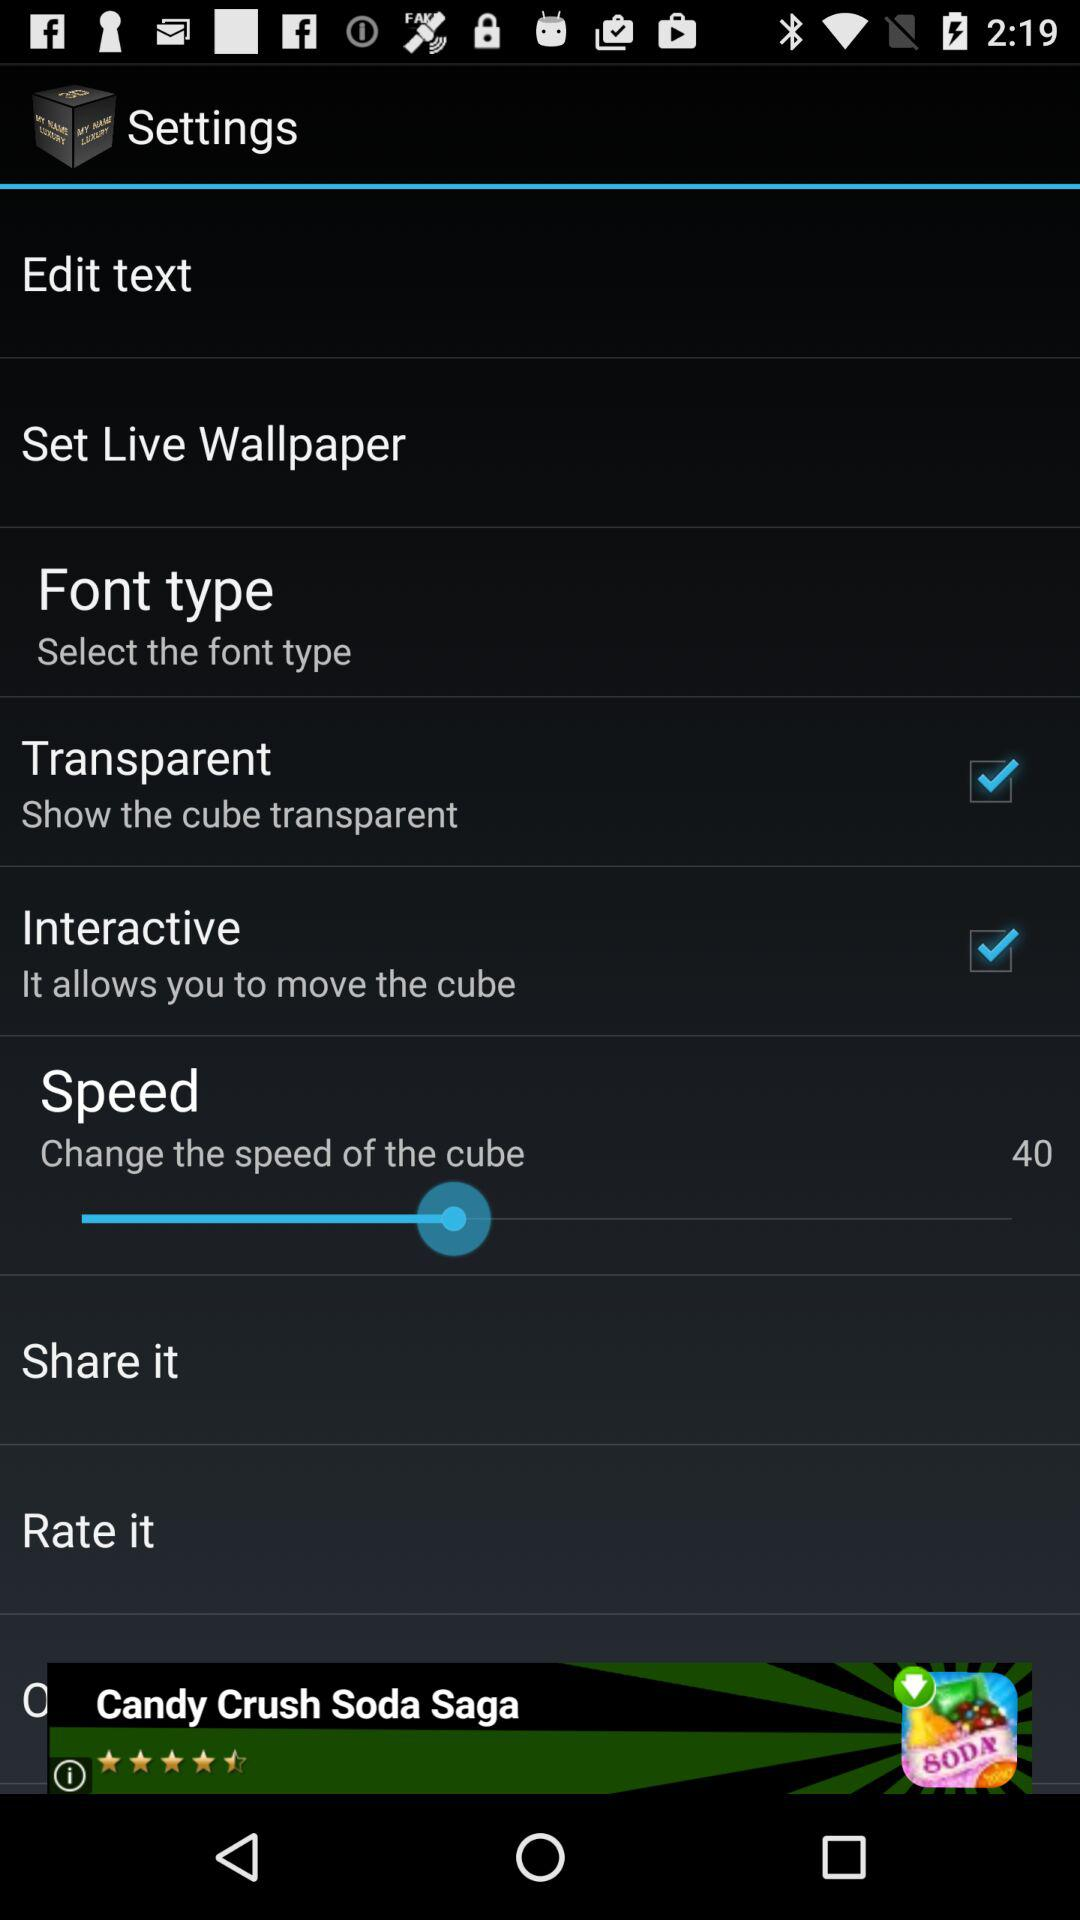Which font type is selected?
When the provided information is insufficient, respond with <no answer>. <no answer> 